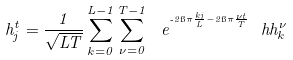<formula> <loc_0><loc_0><loc_500><loc_500>h ^ { t } _ { j } = \frac { 1 } { \sqrt { L T } } \sum _ { k = 0 } ^ { L - 1 } \sum _ { \nu = 0 } ^ { T - 1 } \ e ^ { ^ { \text  -2\i\pi\frac{kj} { L } - 2 \i \pi \frac { \nu t } { T } } } \ h h ^ { \nu } _ { k }</formula> 